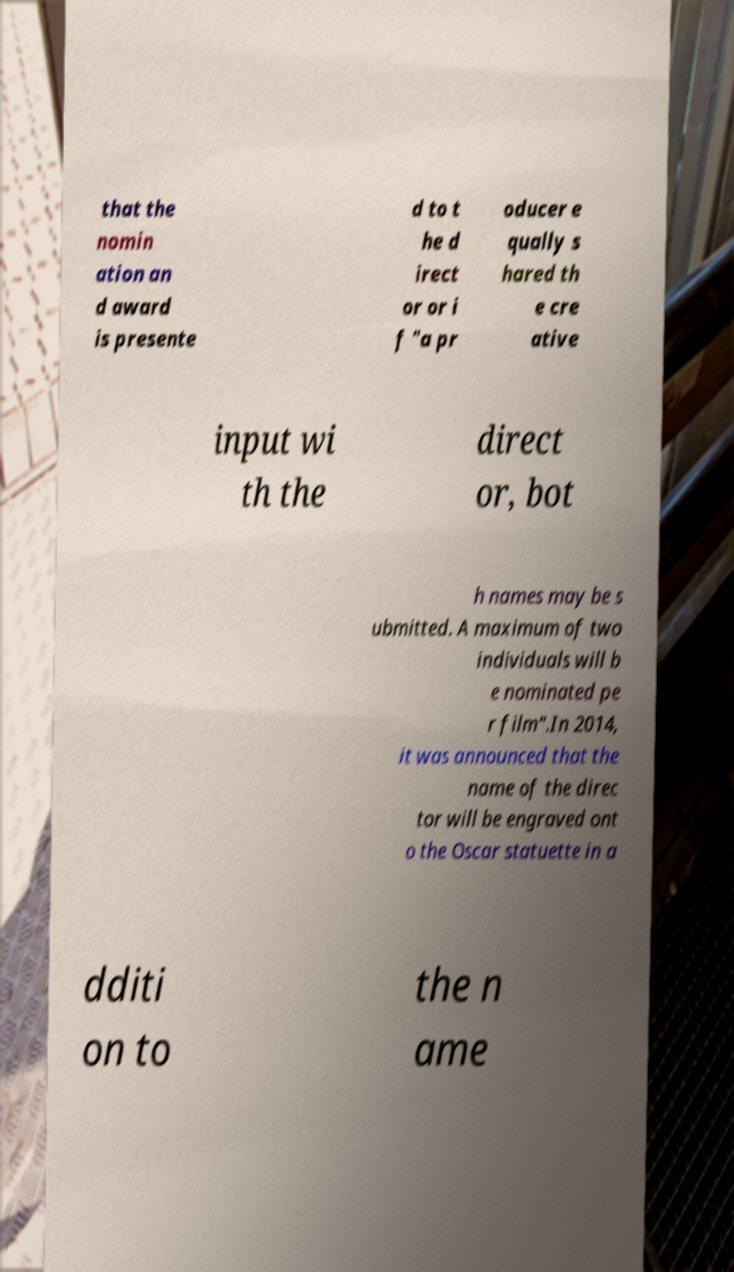Could you assist in decoding the text presented in this image and type it out clearly? that the nomin ation an d award is presente d to t he d irect or or i f "a pr oducer e qually s hared th e cre ative input wi th the direct or, bot h names may be s ubmitted. A maximum of two individuals will b e nominated pe r film".In 2014, it was announced that the name of the direc tor will be engraved ont o the Oscar statuette in a dditi on to the n ame 